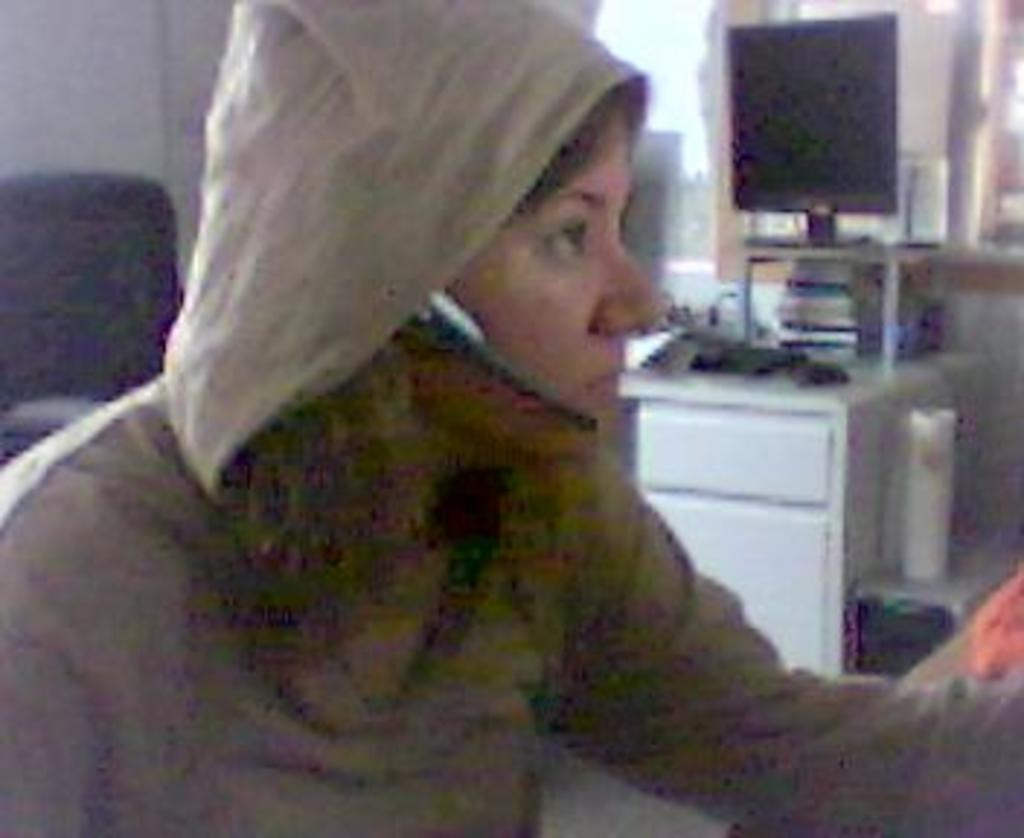Who or what is present in the image? There is a person in the image. What can be seen in the background of the image? There is a wall and a monitor in the background of the image. Are there any other objects visible in the background? Yes, there are some objects in the background of the image. What type of quartz can be seen on the person's body in the image? There is no quartz visible on the person's body in the image. How does the person wash their hands in the image? The image does not show the person washing their hands, so it cannot be determined from the image. 